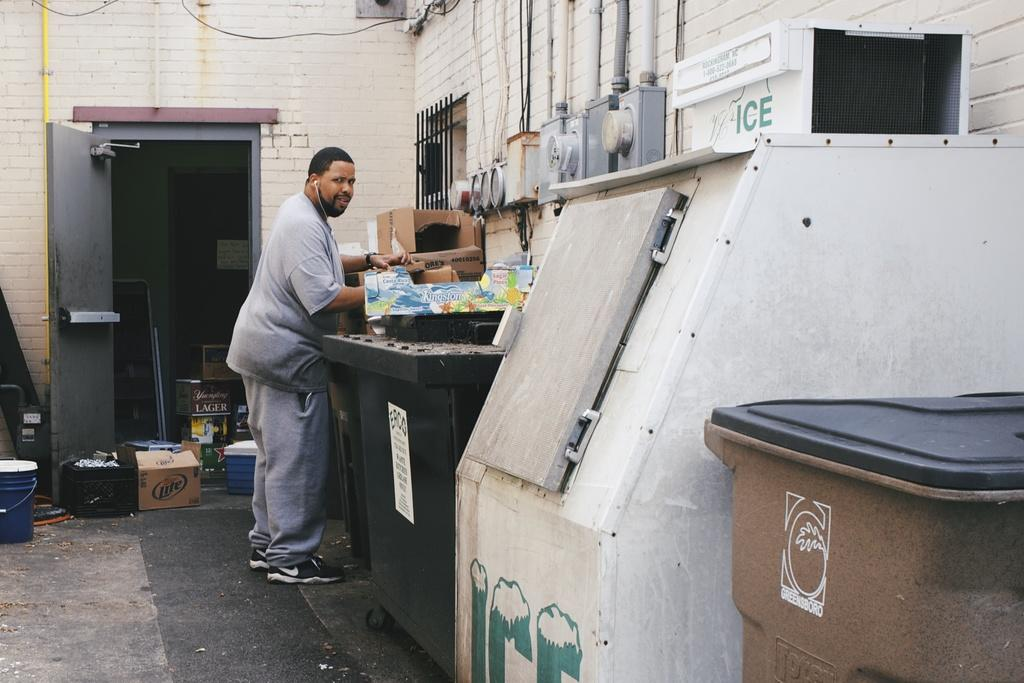<image>
Summarize the visual content of the image. "ICE" is written on an ice box, which is outside. 